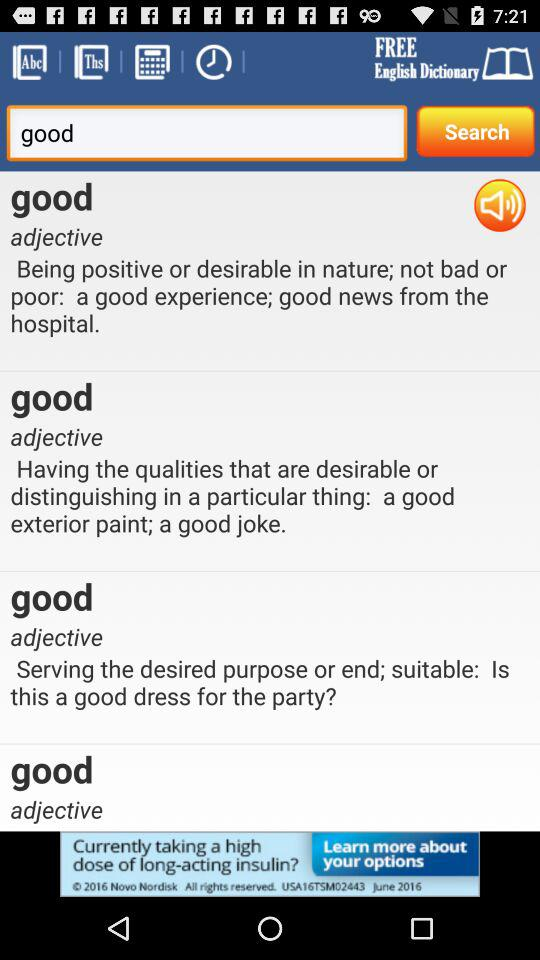What is the name of the application? The name of the application is "FREE English Dictionary". 